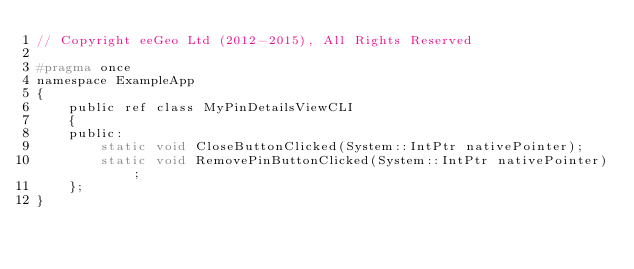Convert code to text. <code><loc_0><loc_0><loc_500><loc_500><_C_>// Copyright eeGeo Ltd (2012-2015), All Rights Reserved

#pragma once
namespace ExampleApp
{
    public ref class MyPinDetailsViewCLI
    {
    public:
        static void CloseButtonClicked(System::IntPtr nativePointer);
        static void RemovePinButtonClicked(System::IntPtr nativePointer);
    };
}
</code> 